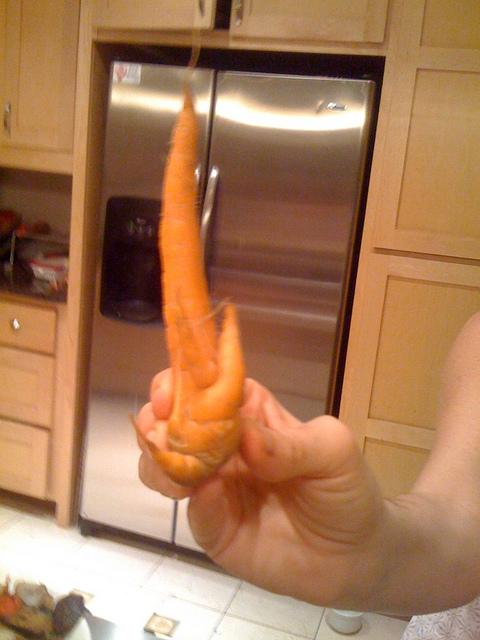Might one imagine a gnome clinging to the base of this carrot?
Give a very brief answer. Yes. What is in the person's hand?
Answer briefly. Carrot. What is behind the woman?
Keep it brief. Refrigerator. 